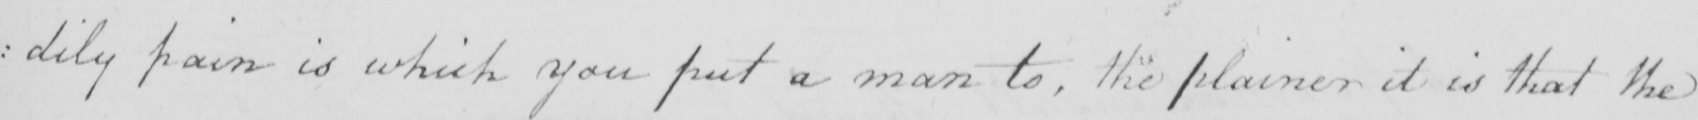Can you read and transcribe this handwriting? : dily pain in which you put a man to , the plainer it is that the 